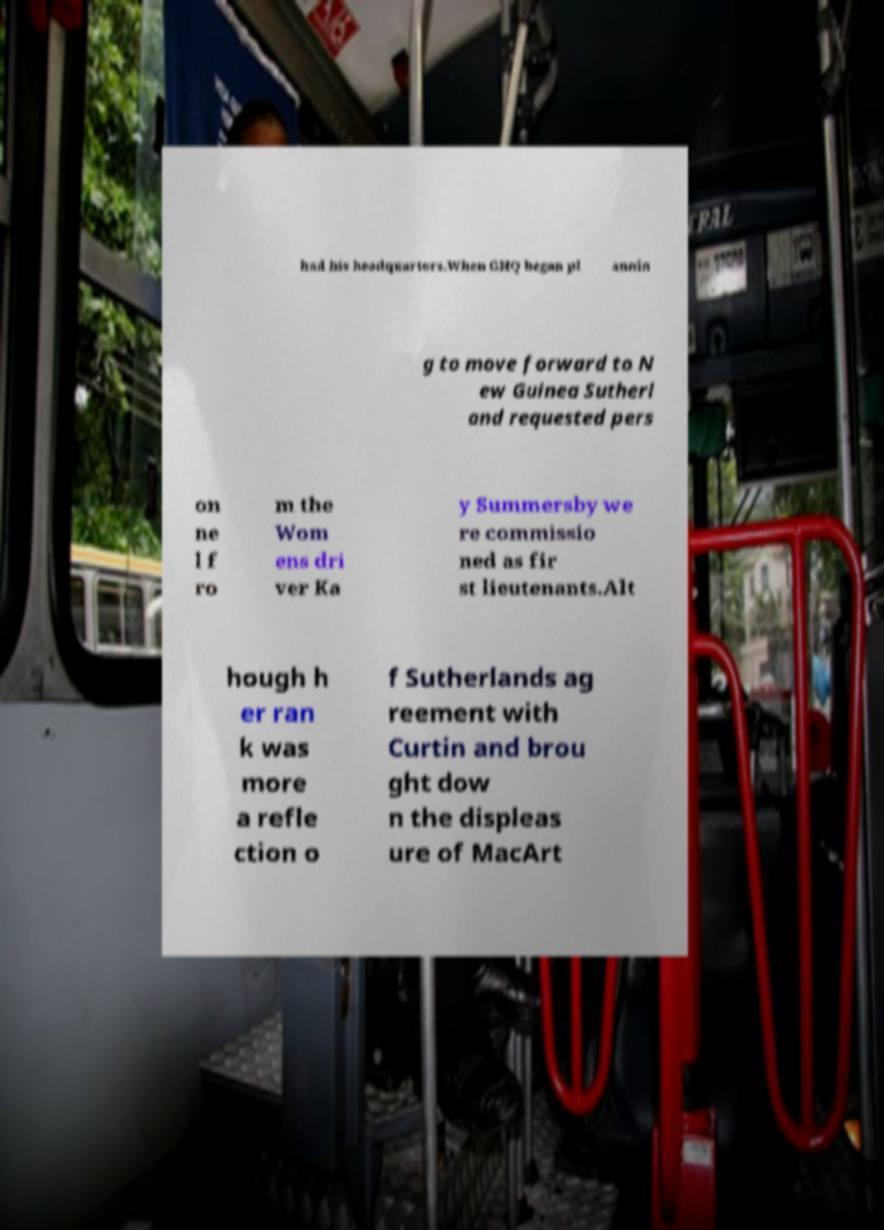Can you accurately transcribe the text from the provided image for me? had his headquarters.When GHQ began pl annin g to move forward to N ew Guinea Sutherl and requested pers on ne l f ro m the Wom ens dri ver Ka y Summersby we re commissio ned as fir st lieutenants.Alt hough h er ran k was more a refle ction o f Sutherlands ag reement with Curtin and brou ght dow n the displeas ure of MacArt 